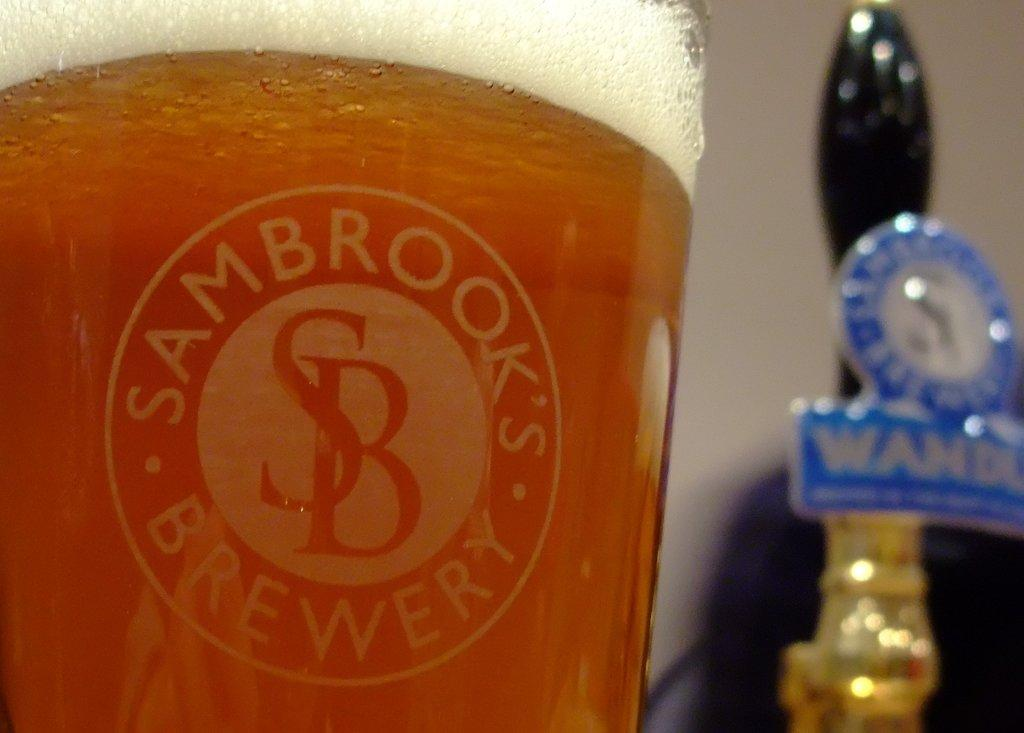<image>
Provide a brief description of the given image. the word brooks that is on a beer cup 